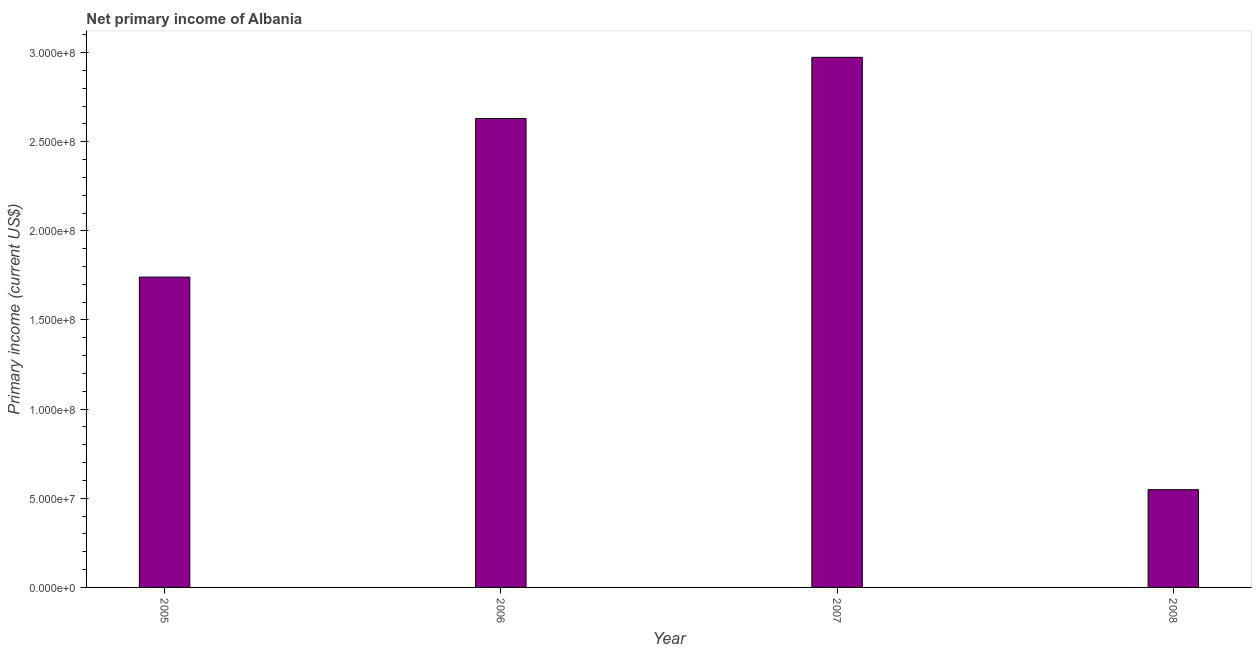Does the graph contain any zero values?
Give a very brief answer. No. Does the graph contain grids?
Keep it short and to the point. No. What is the title of the graph?
Offer a terse response. Net primary income of Albania. What is the label or title of the Y-axis?
Your answer should be very brief. Primary income (current US$). What is the amount of primary income in 2005?
Give a very brief answer. 1.74e+08. Across all years, what is the maximum amount of primary income?
Provide a short and direct response. 2.97e+08. Across all years, what is the minimum amount of primary income?
Provide a succinct answer. 5.48e+07. In which year was the amount of primary income minimum?
Offer a terse response. 2008. What is the sum of the amount of primary income?
Keep it short and to the point. 7.89e+08. What is the difference between the amount of primary income in 2005 and 2008?
Your answer should be compact. 1.19e+08. What is the average amount of primary income per year?
Offer a very short reply. 1.97e+08. What is the median amount of primary income?
Keep it short and to the point. 2.19e+08. Do a majority of the years between 2006 and 2005 (inclusive) have amount of primary income greater than 220000000 US$?
Your response must be concise. No. What is the ratio of the amount of primary income in 2006 to that in 2008?
Your answer should be very brief. 4.8. Is the amount of primary income in 2006 less than that in 2007?
Give a very brief answer. Yes. What is the difference between the highest and the second highest amount of primary income?
Your response must be concise. 3.43e+07. What is the difference between the highest and the lowest amount of primary income?
Make the answer very short. 2.43e+08. In how many years, is the amount of primary income greater than the average amount of primary income taken over all years?
Offer a very short reply. 2. How many bars are there?
Provide a short and direct response. 4. Are all the bars in the graph horizontal?
Your answer should be very brief. No. How many years are there in the graph?
Make the answer very short. 4. Are the values on the major ticks of Y-axis written in scientific E-notation?
Provide a short and direct response. Yes. What is the Primary income (current US$) in 2005?
Keep it short and to the point. 1.74e+08. What is the Primary income (current US$) in 2006?
Provide a short and direct response. 2.63e+08. What is the Primary income (current US$) of 2007?
Your response must be concise. 2.97e+08. What is the Primary income (current US$) in 2008?
Make the answer very short. 5.48e+07. What is the difference between the Primary income (current US$) in 2005 and 2006?
Give a very brief answer. -8.90e+07. What is the difference between the Primary income (current US$) in 2005 and 2007?
Ensure brevity in your answer.  -1.23e+08. What is the difference between the Primary income (current US$) in 2005 and 2008?
Your answer should be very brief. 1.19e+08. What is the difference between the Primary income (current US$) in 2006 and 2007?
Ensure brevity in your answer.  -3.43e+07. What is the difference between the Primary income (current US$) in 2006 and 2008?
Your answer should be compact. 2.08e+08. What is the difference between the Primary income (current US$) in 2007 and 2008?
Provide a short and direct response. 2.43e+08. What is the ratio of the Primary income (current US$) in 2005 to that in 2006?
Offer a very short reply. 0.66. What is the ratio of the Primary income (current US$) in 2005 to that in 2007?
Ensure brevity in your answer.  0.58. What is the ratio of the Primary income (current US$) in 2005 to that in 2008?
Make the answer very short. 3.18. What is the ratio of the Primary income (current US$) in 2006 to that in 2007?
Ensure brevity in your answer.  0.89. What is the ratio of the Primary income (current US$) in 2006 to that in 2008?
Your response must be concise. 4.8. What is the ratio of the Primary income (current US$) in 2007 to that in 2008?
Offer a terse response. 5.42. 